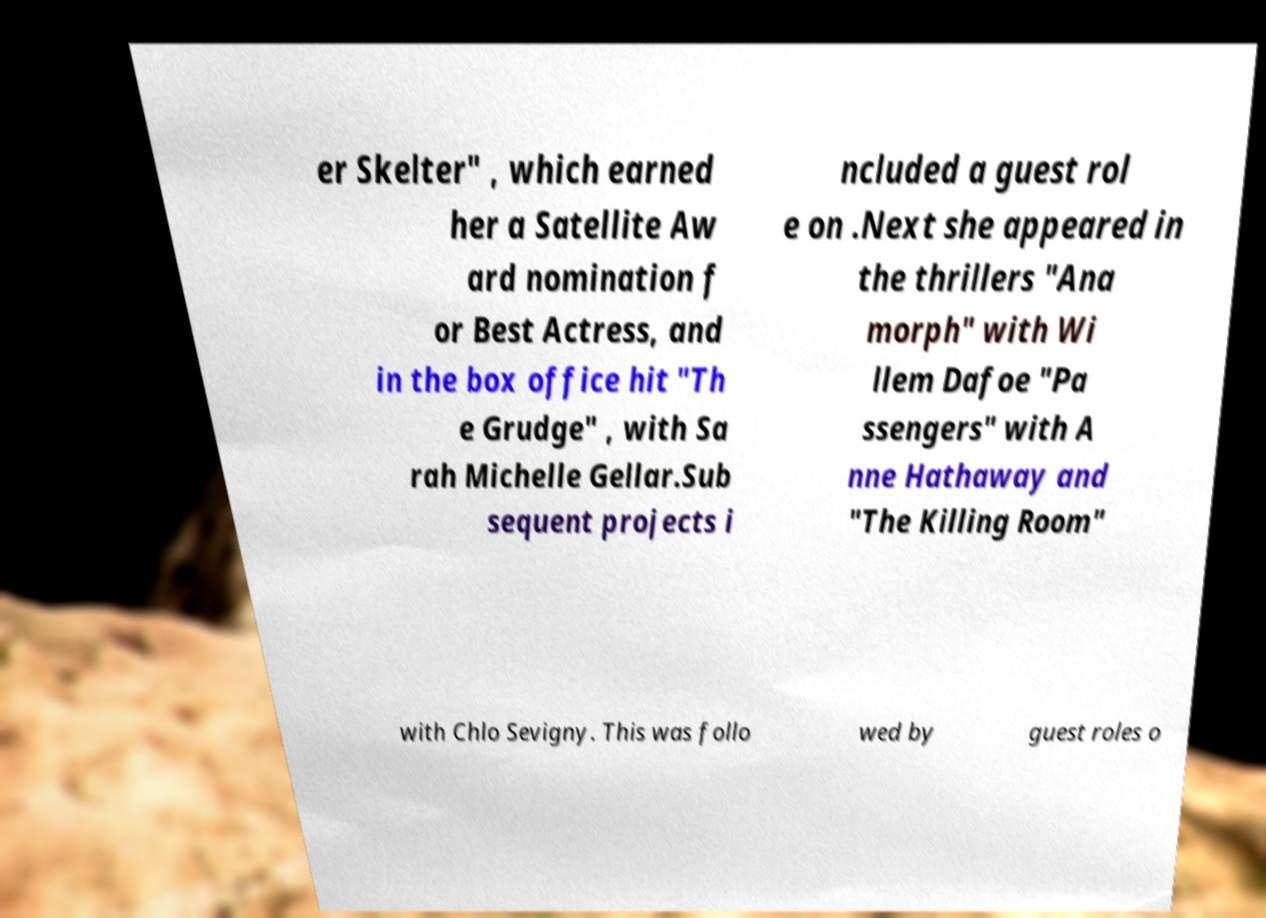Can you read and provide the text displayed in the image?This photo seems to have some interesting text. Can you extract and type it out for me? er Skelter" , which earned her a Satellite Aw ard nomination f or Best Actress, and in the box office hit "Th e Grudge" , with Sa rah Michelle Gellar.Sub sequent projects i ncluded a guest rol e on .Next she appeared in the thrillers "Ana morph" with Wi llem Dafoe "Pa ssengers" with A nne Hathaway and "The Killing Room" with Chlo Sevigny. This was follo wed by guest roles o 